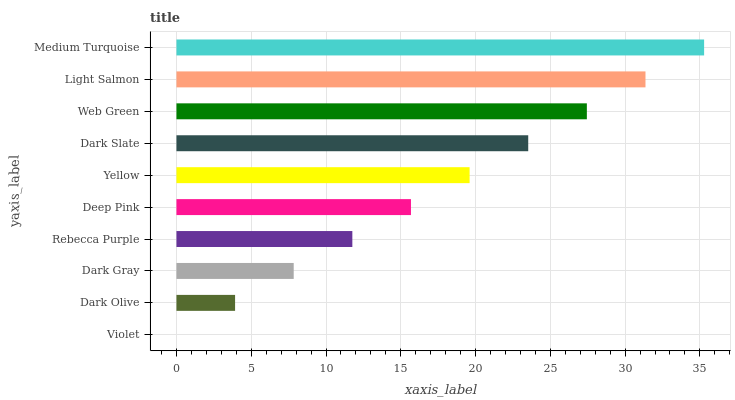Is Violet the minimum?
Answer yes or no. Yes. Is Medium Turquoise the maximum?
Answer yes or no. Yes. Is Dark Olive the minimum?
Answer yes or no. No. Is Dark Olive the maximum?
Answer yes or no. No. Is Dark Olive greater than Violet?
Answer yes or no. Yes. Is Violet less than Dark Olive?
Answer yes or no. Yes. Is Violet greater than Dark Olive?
Answer yes or no. No. Is Dark Olive less than Violet?
Answer yes or no. No. Is Yellow the high median?
Answer yes or no. Yes. Is Deep Pink the low median?
Answer yes or no. Yes. Is Light Salmon the high median?
Answer yes or no. No. Is Dark Gray the low median?
Answer yes or no. No. 